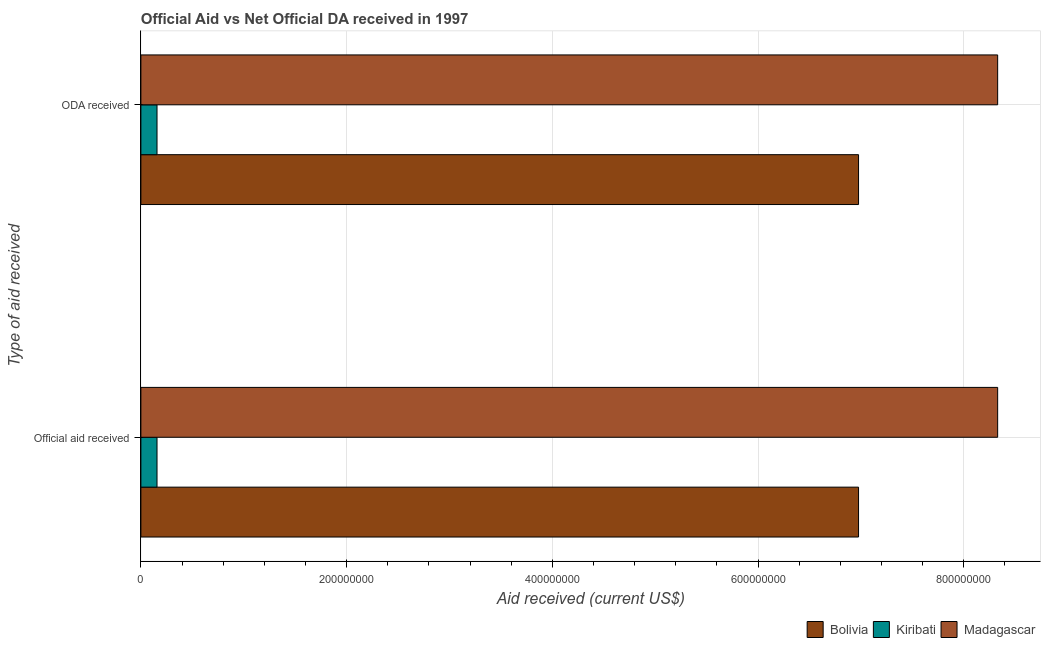How many different coloured bars are there?
Your response must be concise. 3. How many groups of bars are there?
Give a very brief answer. 2. Are the number of bars per tick equal to the number of legend labels?
Provide a short and direct response. Yes. Are the number of bars on each tick of the Y-axis equal?
Keep it short and to the point. Yes. What is the label of the 1st group of bars from the top?
Provide a succinct answer. ODA received. What is the official aid received in Kiribati?
Your answer should be very brief. 1.57e+07. Across all countries, what is the maximum oda received?
Ensure brevity in your answer.  8.33e+08. Across all countries, what is the minimum oda received?
Your answer should be compact. 1.57e+07. In which country was the official aid received maximum?
Your response must be concise. Madagascar. In which country was the official aid received minimum?
Offer a very short reply. Kiribati. What is the total oda received in the graph?
Make the answer very short. 1.55e+09. What is the difference between the oda received in Madagascar and that in Kiribati?
Provide a succinct answer. 8.17e+08. What is the difference between the oda received in Kiribati and the official aid received in Madagascar?
Provide a succinct answer. -8.17e+08. What is the average oda received per country?
Your response must be concise. 5.15e+08. What is the ratio of the official aid received in Bolivia to that in Kiribati?
Provide a succinct answer. 44.5. Is the oda received in Bolivia less than that in Kiribati?
Your answer should be compact. No. What does the 1st bar from the top in Official aid received represents?
Offer a terse response. Madagascar. What does the 2nd bar from the bottom in ODA received represents?
Offer a terse response. Kiribati. How many countries are there in the graph?
Offer a terse response. 3. What is the difference between two consecutive major ticks on the X-axis?
Keep it short and to the point. 2.00e+08. Does the graph contain grids?
Your answer should be compact. Yes. What is the title of the graph?
Your answer should be very brief. Official Aid vs Net Official DA received in 1997 . Does "United Arab Emirates" appear as one of the legend labels in the graph?
Your answer should be compact. No. What is the label or title of the X-axis?
Give a very brief answer. Aid received (current US$). What is the label or title of the Y-axis?
Your response must be concise. Type of aid received. What is the Aid received (current US$) of Bolivia in Official aid received?
Offer a very short reply. 6.98e+08. What is the Aid received (current US$) in Kiribati in Official aid received?
Ensure brevity in your answer.  1.57e+07. What is the Aid received (current US$) in Madagascar in Official aid received?
Your answer should be very brief. 8.33e+08. What is the Aid received (current US$) of Bolivia in ODA received?
Offer a terse response. 6.98e+08. What is the Aid received (current US$) in Kiribati in ODA received?
Your answer should be very brief. 1.57e+07. What is the Aid received (current US$) in Madagascar in ODA received?
Provide a succinct answer. 8.33e+08. Across all Type of aid received, what is the maximum Aid received (current US$) of Bolivia?
Your answer should be very brief. 6.98e+08. Across all Type of aid received, what is the maximum Aid received (current US$) in Kiribati?
Ensure brevity in your answer.  1.57e+07. Across all Type of aid received, what is the maximum Aid received (current US$) in Madagascar?
Your answer should be very brief. 8.33e+08. Across all Type of aid received, what is the minimum Aid received (current US$) of Bolivia?
Make the answer very short. 6.98e+08. Across all Type of aid received, what is the minimum Aid received (current US$) of Kiribati?
Provide a short and direct response. 1.57e+07. Across all Type of aid received, what is the minimum Aid received (current US$) of Madagascar?
Your answer should be very brief. 8.33e+08. What is the total Aid received (current US$) of Bolivia in the graph?
Make the answer very short. 1.40e+09. What is the total Aid received (current US$) in Kiribati in the graph?
Your answer should be very brief. 3.14e+07. What is the total Aid received (current US$) of Madagascar in the graph?
Offer a very short reply. 1.67e+09. What is the difference between the Aid received (current US$) in Bolivia in Official aid received and that in ODA received?
Your answer should be compact. 0. What is the difference between the Aid received (current US$) of Bolivia in Official aid received and the Aid received (current US$) of Kiribati in ODA received?
Offer a terse response. 6.82e+08. What is the difference between the Aid received (current US$) of Bolivia in Official aid received and the Aid received (current US$) of Madagascar in ODA received?
Your response must be concise. -1.35e+08. What is the difference between the Aid received (current US$) of Kiribati in Official aid received and the Aid received (current US$) of Madagascar in ODA received?
Offer a very short reply. -8.17e+08. What is the average Aid received (current US$) in Bolivia per Type of aid received?
Provide a short and direct response. 6.98e+08. What is the average Aid received (current US$) in Kiribati per Type of aid received?
Ensure brevity in your answer.  1.57e+07. What is the average Aid received (current US$) of Madagascar per Type of aid received?
Your answer should be very brief. 8.33e+08. What is the difference between the Aid received (current US$) of Bolivia and Aid received (current US$) of Kiribati in Official aid received?
Keep it short and to the point. 6.82e+08. What is the difference between the Aid received (current US$) of Bolivia and Aid received (current US$) of Madagascar in Official aid received?
Provide a short and direct response. -1.35e+08. What is the difference between the Aid received (current US$) of Kiribati and Aid received (current US$) of Madagascar in Official aid received?
Provide a short and direct response. -8.17e+08. What is the difference between the Aid received (current US$) of Bolivia and Aid received (current US$) of Kiribati in ODA received?
Keep it short and to the point. 6.82e+08. What is the difference between the Aid received (current US$) in Bolivia and Aid received (current US$) in Madagascar in ODA received?
Ensure brevity in your answer.  -1.35e+08. What is the difference between the Aid received (current US$) of Kiribati and Aid received (current US$) of Madagascar in ODA received?
Make the answer very short. -8.17e+08. What is the ratio of the Aid received (current US$) of Bolivia in Official aid received to that in ODA received?
Your answer should be very brief. 1. What is the ratio of the Aid received (current US$) of Kiribati in Official aid received to that in ODA received?
Offer a terse response. 1. What is the ratio of the Aid received (current US$) of Madagascar in Official aid received to that in ODA received?
Ensure brevity in your answer.  1. What is the difference between the highest and the second highest Aid received (current US$) of Kiribati?
Offer a very short reply. 0. What is the difference between the highest and the second highest Aid received (current US$) in Madagascar?
Give a very brief answer. 0. What is the difference between the highest and the lowest Aid received (current US$) of Bolivia?
Your response must be concise. 0. What is the difference between the highest and the lowest Aid received (current US$) in Madagascar?
Keep it short and to the point. 0. 